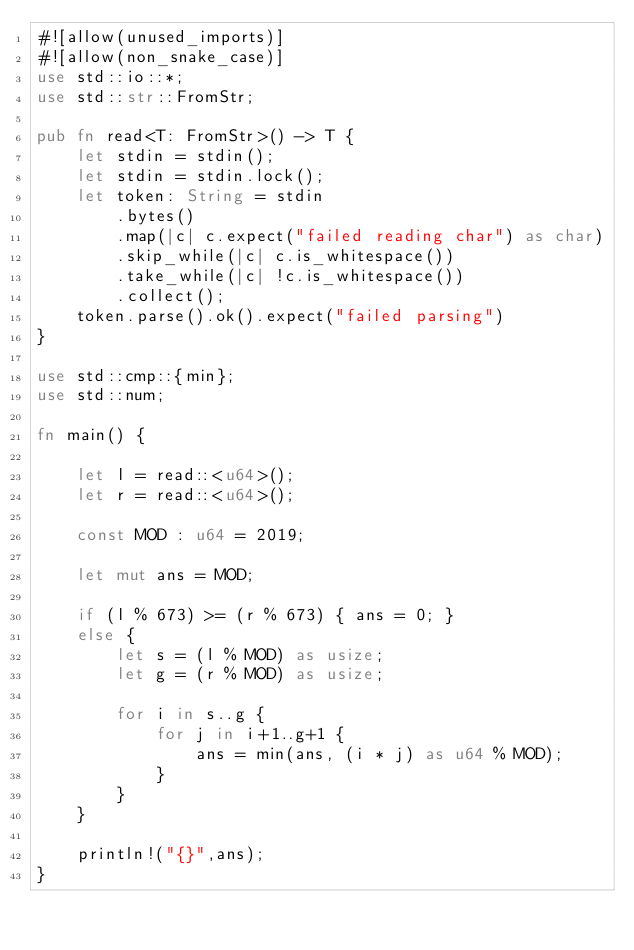<code> <loc_0><loc_0><loc_500><loc_500><_Rust_>#![allow(unused_imports)]
#![allow(non_snake_case)]
use std::io::*;
use std::str::FromStr;

pub fn read<T: FromStr>() -> T {
    let stdin = stdin();
    let stdin = stdin.lock();
    let token: String = stdin
        .bytes()
        .map(|c| c.expect("failed reading char") as char)
        .skip_while(|c| c.is_whitespace())
        .take_while(|c| !c.is_whitespace())
        .collect();
    token.parse().ok().expect("failed parsing")
}

use std::cmp::{min};
use std::num;

fn main() {
    
    let l = read::<u64>();
    let r = read::<u64>();
    
    const MOD : u64 = 2019;
    
    let mut ans = MOD;
    
    if (l % 673) >= (r % 673) { ans = 0; }
    else {
        let s = (l % MOD) as usize;
        let g = (r % MOD) as usize;
        
        for i in s..g {
            for j in i+1..g+1 {
                ans = min(ans, (i * j) as u64 % MOD);
            }
        }
    }
    
    println!("{}",ans);
}</code> 